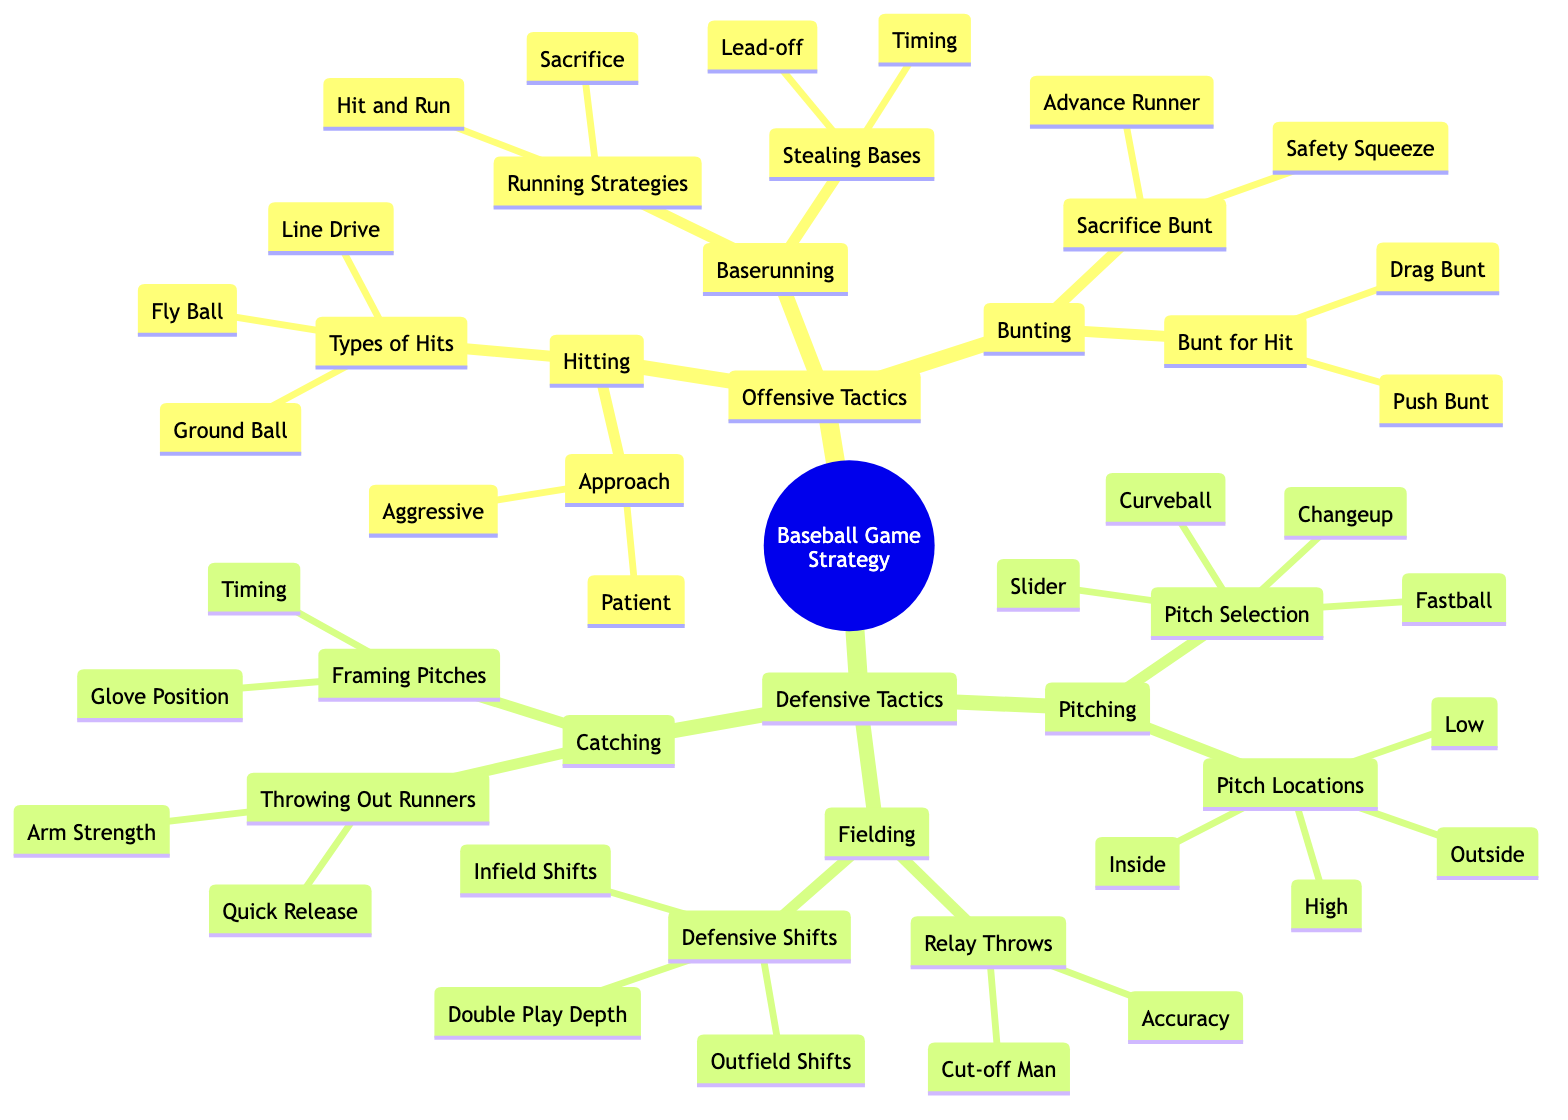What are the two hitting approaches listed in the diagram? The diagram lists two hitting approaches under the Hitting section. They are located under the "Approach" node. I can directly see that they are "Aggressive" and "Patient."
Answer: Aggressive, Patient How many types of hits are shown in the offensive tactics? The diagram indicates three types of hits under the "Types of Hits" node in the Hitting section. They include "Line Drive," "Ground Ball," and "Fly Ball," which can be counted directly from the diagram.
Answer: 3 Name one running strategy included in the baserunning tactics. The Running Strategies node in the Baserunning section contains two options: "Hit and Run" and "Sacrifice." I can choose either one directly as they are both listed there.
Answer: Hit and Run What is one type of pitching strategy found in the diagram? In the Pitching section, there is a "Pitch Selection" node that lists various pitches. Looking at this node, I see "Fastball," "Curveball," "Slider," and "Changeup." Therefore, I can choose any of these types as an answer.
Answer: Fastball Which defensive tactic involves accurate throws? The Relay Throws section under Fielding lists "Accuracy" as one of the components that contribute to relay throws. This indicates the focus on making accurate throws when executing this defensive tactic.
Answer: Accuracy How many different types of bunts are listed in the diagram? From the Bunting section, there are two main categories: "Sacrifice Bunt" and "Bunt for Hit." Under each of these categories, we find two types of bunts being specified. By counting them, I find there are a total of four distinct bunting types provided in the diagram.
Answer: 4 What is the significance of “Double Play Depth” in the defensive tactics? The term "Double Play Depth" appears under the Defensive Shifts category of Fielding. This indicates a strategy specifically aimed at positioning players in such a way as to maximize the opportunity for a double play, a key defensive tactic in baseball.
Answer: Maximizing double play opportunities Name one aspect of framing pitches according to the diagram. In the Catching section, under Framing Pitches, there are two aspects mentioned: "Glove Position" and "Timing." Either of these can be selected as a correct answer based on the information presented in the diagram.
Answer: Glove Position 